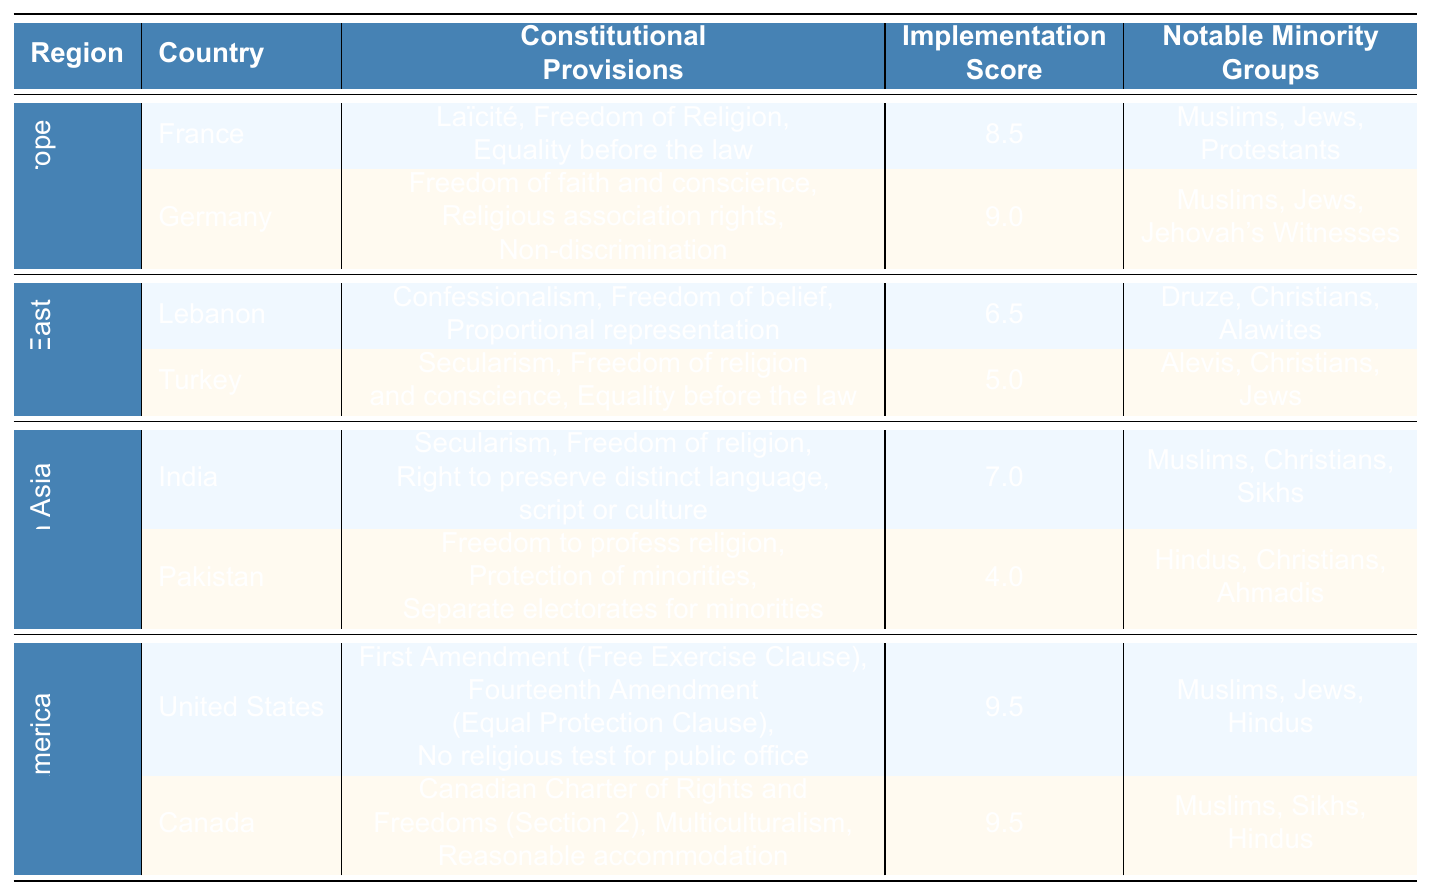What is the highest implementation score in the table? The implementation scores for each country are listed. The highest score is 9.5, which appears for both the United States and Canada.
Answer: 9.5 Which country has the lowest implementation score? Looking at the implementation scores, Pakistan has the lowest score at 4.0.
Answer: Pakistan List a notable minority group from Germany. The table lists the notable minority groups associated with each country. For Germany, the notable minority groups include Muslims, Jews, and Jehovah's Witnesses.
Answer: Muslims, Jews, Jehovah's Witnesses Which region has the highest average implementation score? To calculate the average implementation score for each region, I sum the implementation scores of the countries in that region and divide by the number of countries: Western Europe (8.5 + 9.0)/2 = 8.75, Middle East (6.5 + 5.0)/2 = 5.75, South Asia (7.0 + 4.0)/2 = 5.50, North America (9.5 + 9.5)/2 = 9.5. The highest average is in North America at 9.5.
Answer: North America Is there any country with a score of 6.0 or higher in the Middle East? The implementation scores for Lebanon and Turkey in the Middle East are 6.5 and 5.0, respectively. Since Lebanon's score is above 6.0, the answer is yes.
Answer: Yes Which country in South Asia provides a right to preserve distinct language, script, or culture? According to the table, India includes a constitutional provision stating the right to preserve distinct language, script, or culture.
Answer: India How many notable minority groups are mentioned for the United States? The United States lists three notable minority groups in the table: Muslims, Jews, and Hindus.
Answer: 3 Compare the implementation scores of France and Lebanon. France has an implementation score of 8.5, while Lebanon has a score of 6.5. The difference in their scores is 8.5 - 6.5 = 2.0. Thus, France has a higher implementation score than Lebanon by 2.0.
Answer: France has a higher score by 2.0 Which region has the largest diversity of notable minority groups? Looking at the notable minority groups listed, the North America region has a notable diversity with groups including Muslims, Sikhs, Hindus, in addition to those listed in other regions. However, evaluating all groups, Western Europe also has three distinct groups. Thus, both Western Europe and North America have substantial diversity of notable minority groups, but North America stands out with cultural policies promoting diversity.
Answer: North America Does Turkey recognize freedom of belief as a constitutional provision? The table indicates that Turkey includes freedom of religion and conscience as part of its constitutional provisions, which implies recognition of freedom of belief.
Answer: Yes 